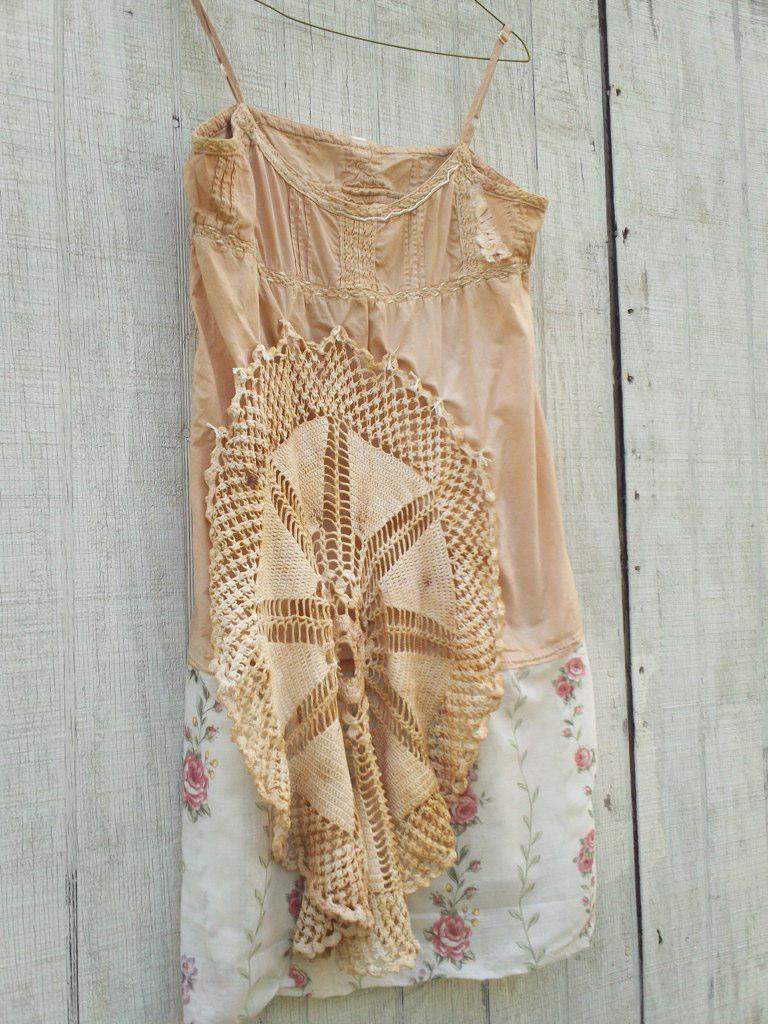Can you describe this image briefly? In this image we can see a dress on a cloth hanger. In the background, we can see the wall. 